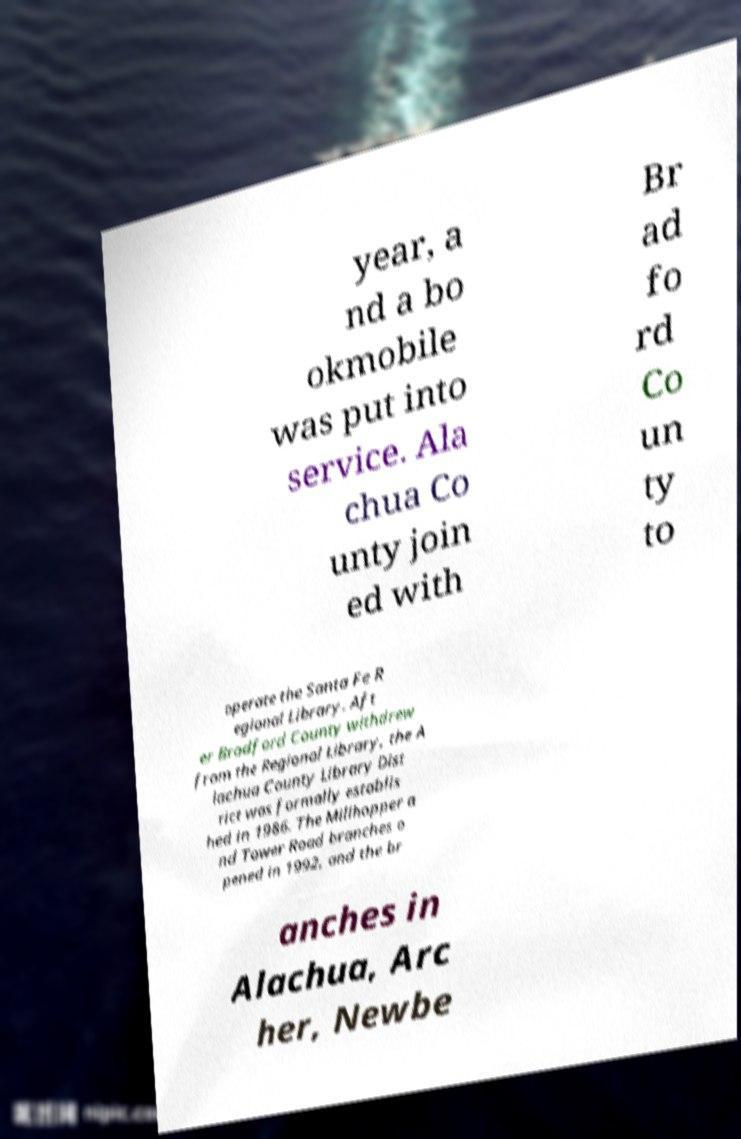Can you read and provide the text displayed in the image?This photo seems to have some interesting text. Can you extract and type it out for me? year, a nd a bo okmobile was put into service. Ala chua Co unty join ed with Br ad fo rd Co un ty to operate the Santa Fe R egional Library. Aft er Bradford County withdrew from the Regional Library, the A lachua County Library Dist rict was formally establis hed in 1986. The Millhopper a nd Tower Road branches o pened in 1992, and the br anches in Alachua, Arc her, Newbe 